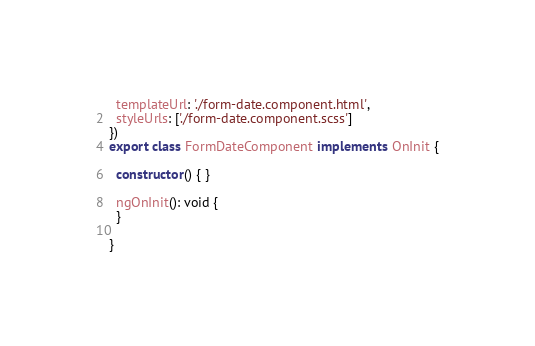Convert code to text. <code><loc_0><loc_0><loc_500><loc_500><_TypeScript_>  templateUrl: './form-date.component.html',
  styleUrls: ['./form-date.component.scss']
})
export class FormDateComponent implements OnInit {

  constructor() { }

  ngOnInit(): void {
  }

}
</code> 